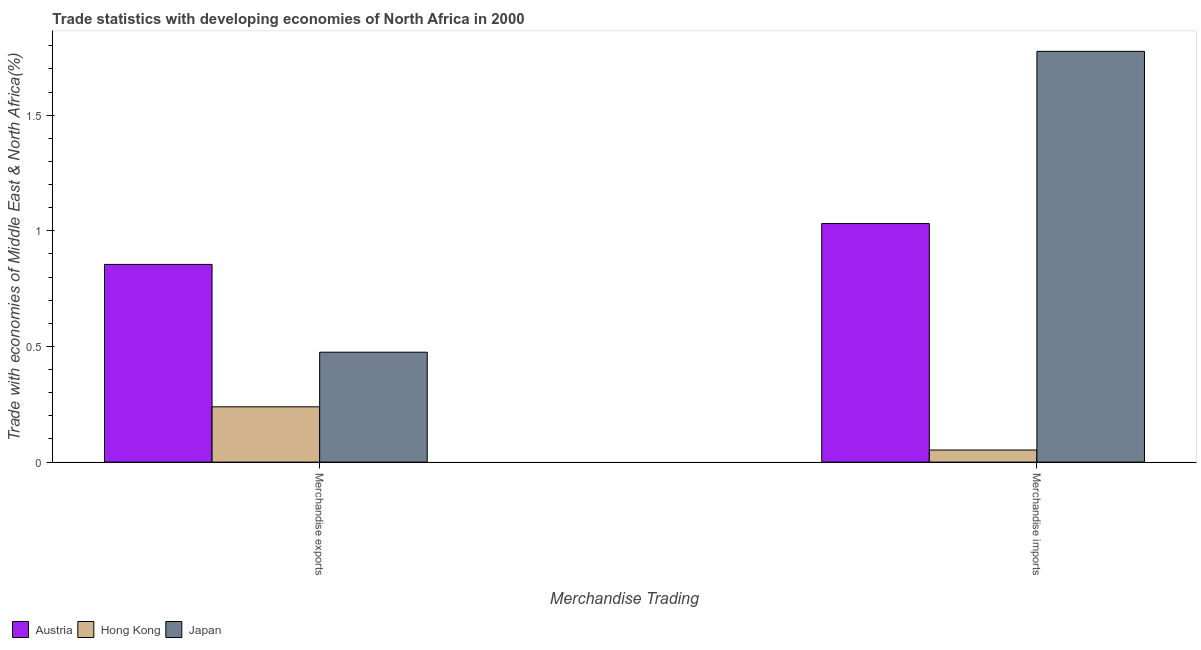How many different coloured bars are there?
Offer a very short reply. 3. How many groups of bars are there?
Provide a short and direct response. 2. How many bars are there on the 2nd tick from the left?
Offer a terse response. 3. What is the label of the 1st group of bars from the left?
Your answer should be very brief. Merchandise exports. What is the merchandise imports in Austria?
Keep it short and to the point. 1.03. Across all countries, what is the maximum merchandise imports?
Provide a succinct answer. 1.78. Across all countries, what is the minimum merchandise imports?
Your answer should be compact. 0.05. In which country was the merchandise exports minimum?
Provide a succinct answer. Hong Kong. What is the total merchandise imports in the graph?
Your answer should be very brief. 2.86. What is the difference between the merchandise imports in Japan and that in Hong Kong?
Offer a terse response. 1.72. What is the difference between the merchandise imports in Japan and the merchandise exports in Austria?
Offer a terse response. 0.92. What is the average merchandise imports per country?
Provide a short and direct response. 0.95. What is the difference between the merchandise imports and merchandise exports in Hong Kong?
Make the answer very short. -0.19. What is the ratio of the merchandise imports in Hong Kong to that in Japan?
Provide a succinct answer. 0.03. What does the 2nd bar from the left in Merchandise exports represents?
Provide a succinct answer. Hong Kong. What does the 2nd bar from the right in Merchandise imports represents?
Give a very brief answer. Hong Kong. How many bars are there?
Make the answer very short. 6. Are all the bars in the graph horizontal?
Your response must be concise. No. How many countries are there in the graph?
Make the answer very short. 3. Does the graph contain any zero values?
Give a very brief answer. No. Does the graph contain grids?
Your response must be concise. No. Where does the legend appear in the graph?
Keep it short and to the point. Bottom left. What is the title of the graph?
Provide a succinct answer. Trade statistics with developing economies of North Africa in 2000. Does "Tanzania" appear as one of the legend labels in the graph?
Ensure brevity in your answer.  No. What is the label or title of the X-axis?
Your answer should be compact. Merchandise Trading. What is the label or title of the Y-axis?
Give a very brief answer. Trade with economies of Middle East & North Africa(%). What is the Trade with economies of Middle East & North Africa(%) in Austria in Merchandise exports?
Make the answer very short. 0.85. What is the Trade with economies of Middle East & North Africa(%) in Hong Kong in Merchandise exports?
Provide a succinct answer. 0.24. What is the Trade with economies of Middle East & North Africa(%) of Japan in Merchandise exports?
Make the answer very short. 0.48. What is the Trade with economies of Middle East & North Africa(%) in Austria in Merchandise imports?
Your response must be concise. 1.03. What is the Trade with economies of Middle East & North Africa(%) of Hong Kong in Merchandise imports?
Keep it short and to the point. 0.05. What is the Trade with economies of Middle East & North Africa(%) in Japan in Merchandise imports?
Keep it short and to the point. 1.78. Across all Merchandise Trading, what is the maximum Trade with economies of Middle East & North Africa(%) in Austria?
Your answer should be compact. 1.03. Across all Merchandise Trading, what is the maximum Trade with economies of Middle East & North Africa(%) of Hong Kong?
Make the answer very short. 0.24. Across all Merchandise Trading, what is the maximum Trade with economies of Middle East & North Africa(%) in Japan?
Offer a terse response. 1.78. Across all Merchandise Trading, what is the minimum Trade with economies of Middle East & North Africa(%) of Austria?
Your answer should be very brief. 0.85. Across all Merchandise Trading, what is the minimum Trade with economies of Middle East & North Africa(%) in Hong Kong?
Give a very brief answer. 0.05. Across all Merchandise Trading, what is the minimum Trade with economies of Middle East & North Africa(%) of Japan?
Provide a succinct answer. 0.48. What is the total Trade with economies of Middle East & North Africa(%) in Austria in the graph?
Make the answer very short. 1.89. What is the total Trade with economies of Middle East & North Africa(%) in Hong Kong in the graph?
Your answer should be compact. 0.29. What is the total Trade with economies of Middle East & North Africa(%) of Japan in the graph?
Offer a very short reply. 2.25. What is the difference between the Trade with economies of Middle East & North Africa(%) of Austria in Merchandise exports and that in Merchandise imports?
Your answer should be very brief. -0.18. What is the difference between the Trade with economies of Middle East & North Africa(%) in Hong Kong in Merchandise exports and that in Merchandise imports?
Provide a succinct answer. 0.19. What is the difference between the Trade with economies of Middle East & North Africa(%) of Japan in Merchandise exports and that in Merchandise imports?
Offer a very short reply. -1.3. What is the difference between the Trade with economies of Middle East & North Africa(%) in Austria in Merchandise exports and the Trade with economies of Middle East & North Africa(%) in Hong Kong in Merchandise imports?
Give a very brief answer. 0.8. What is the difference between the Trade with economies of Middle East & North Africa(%) of Austria in Merchandise exports and the Trade with economies of Middle East & North Africa(%) of Japan in Merchandise imports?
Make the answer very short. -0.92. What is the difference between the Trade with economies of Middle East & North Africa(%) of Hong Kong in Merchandise exports and the Trade with economies of Middle East & North Africa(%) of Japan in Merchandise imports?
Give a very brief answer. -1.54. What is the average Trade with economies of Middle East & North Africa(%) in Austria per Merchandise Trading?
Give a very brief answer. 0.94. What is the average Trade with economies of Middle East & North Africa(%) of Hong Kong per Merchandise Trading?
Provide a short and direct response. 0.15. What is the average Trade with economies of Middle East & North Africa(%) of Japan per Merchandise Trading?
Provide a short and direct response. 1.13. What is the difference between the Trade with economies of Middle East & North Africa(%) in Austria and Trade with economies of Middle East & North Africa(%) in Hong Kong in Merchandise exports?
Give a very brief answer. 0.62. What is the difference between the Trade with economies of Middle East & North Africa(%) of Austria and Trade with economies of Middle East & North Africa(%) of Japan in Merchandise exports?
Offer a very short reply. 0.38. What is the difference between the Trade with economies of Middle East & North Africa(%) of Hong Kong and Trade with economies of Middle East & North Africa(%) of Japan in Merchandise exports?
Provide a short and direct response. -0.24. What is the difference between the Trade with economies of Middle East & North Africa(%) in Austria and Trade with economies of Middle East & North Africa(%) in Japan in Merchandise imports?
Provide a short and direct response. -0.74. What is the difference between the Trade with economies of Middle East & North Africa(%) in Hong Kong and Trade with economies of Middle East & North Africa(%) in Japan in Merchandise imports?
Offer a very short reply. -1.72. What is the ratio of the Trade with economies of Middle East & North Africa(%) in Austria in Merchandise exports to that in Merchandise imports?
Provide a succinct answer. 0.83. What is the ratio of the Trade with economies of Middle East & North Africa(%) in Hong Kong in Merchandise exports to that in Merchandise imports?
Give a very brief answer. 4.57. What is the ratio of the Trade with economies of Middle East & North Africa(%) of Japan in Merchandise exports to that in Merchandise imports?
Keep it short and to the point. 0.27. What is the difference between the highest and the second highest Trade with economies of Middle East & North Africa(%) of Austria?
Give a very brief answer. 0.18. What is the difference between the highest and the second highest Trade with economies of Middle East & North Africa(%) in Hong Kong?
Your answer should be very brief. 0.19. What is the difference between the highest and the second highest Trade with economies of Middle East & North Africa(%) of Japan?
Keep it short and to the point. 1.3. What is the difference between the highest and the lowest Trade with economies of Middle East & North Africa(%) of Austria?
Give a very brief answer. 0.18. What is the difference between the highest and the lowest Trade with economies of Middle East & North Africa(%) in Hong Kong?
Your response must be concise. 0.19. What is the difference between the highest and the lowest Trade with economies of Middle East & North Africa(%) in Japan?
Provide a short and direct response. 1.3. 